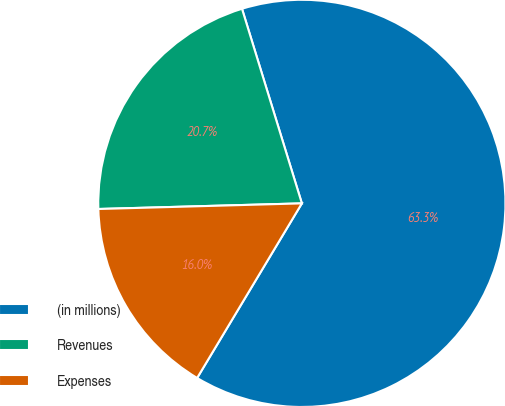Convert chart to OTSL. <chart><loc_0><loc_0><loc_500><loc_500><pie_chart><fcel>(in millions)<fcel>Revenues<fcel>Expenses<nl><fcel>63.35%<fcel>20.69%<fcel>15.96%<nl></chart> 